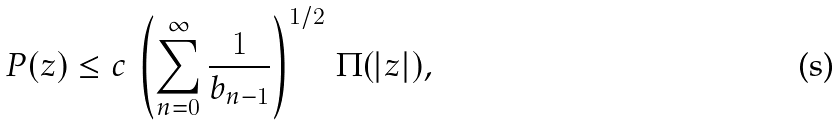<formula> <loc_0><loc_0><loc_500><loc_500>P ( z ) \leq c \, \left ( \sum _ { n = 0 } ^ { \infty } \frac { 1 } { b _ { n - 1 } } \right ) ^ { 1 / 2 } \, \Pi ( | z | ) ,</formula> 